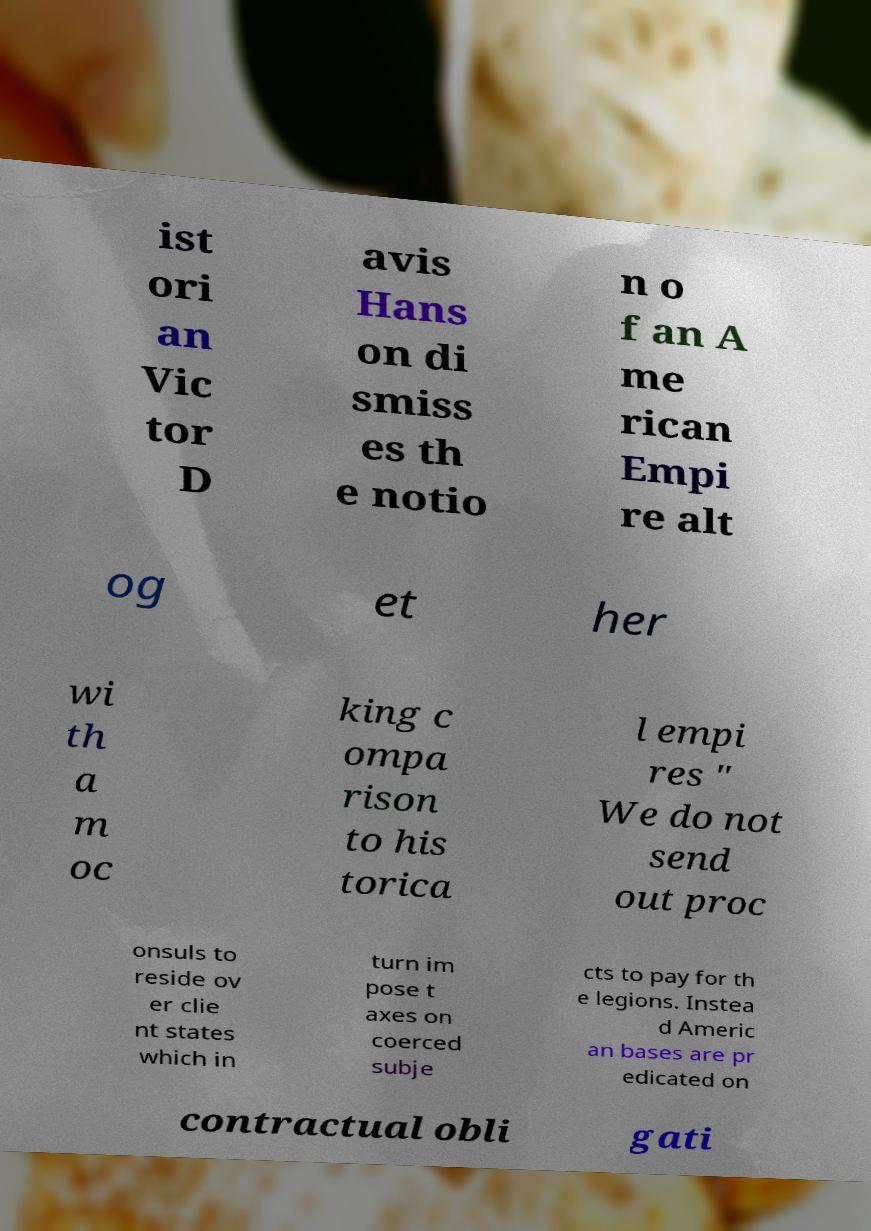Can you read and provide the text displayed in the image?This photo seems to have some interesting text. Can you extract and type it out for me? ist ori an Vic tor D avis Hans on di smiss es th e notio n o f an A me rican Empi re alt og et her wi th a m oc king c ompa rison to his torica l empi res " We do not send out proc onsuls to reside ov er clie nt states which in turn im pose t axes on coerced subje cts to pay for th e legions. Instea d Americ an bases are pr edicated on contractual obli gati 